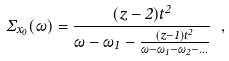<formula> <loc_0><loc_0><loc_500><loc_500>\Sigma _ { x _ { 0 } } ( \omega ) = \frac { ( z - 2 ) t ^ { 2 } } { \omega - \omega _ { 1 } - \frac { ( z - 1 ) t ^ { 2 } } { \omega - \omega _ { 1 } - \omega _ { 2 } - \dots } } \ ,</formula> 